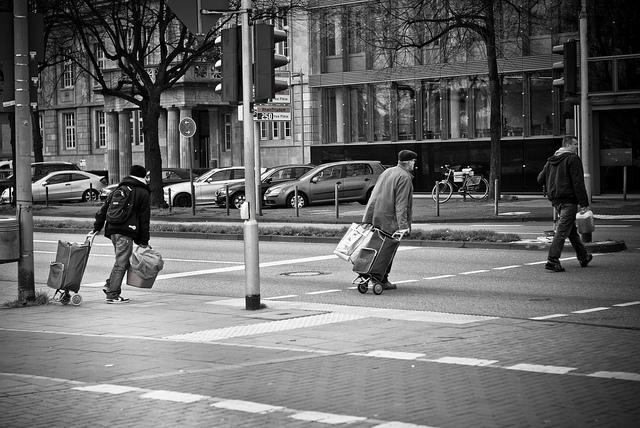What shape are the dark tiles arranged in?
Concise answer only. Square. How many people are in the road?
Concise answer only. 3. Does it look like it's been raining?
Concise answer only. No. Where are they going?
Keep it brief. Home. How many people are there?
Be succinct. 3. What are the people pushing?
Short answer required. Carts. Have they been shopping?
Answer briefly. Yes. Does the man have long hair?
Give a very brief answer. No. Did the pedestrians agree to space themselves apart?
Give a very brief answer. No. 